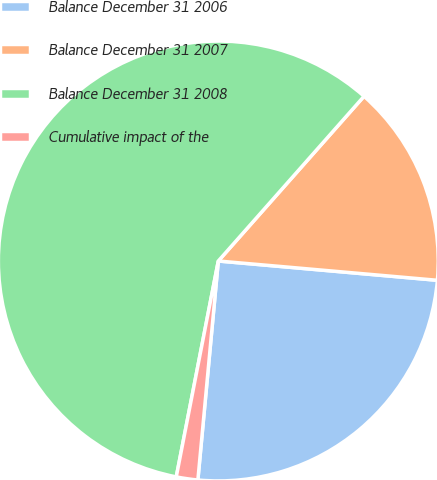<chart> <loc_0><loc_0><loc_500><loc_500><pie_chart><fcel>Balance December 31 2006<fcel>Balance December 31 2007<fcel>Balance December 31 2008<fcel>Cumulative impact of the<nl><fcel>25.08%<fcel>14.87%<fcel>58.46%<fcel>1.58%<nl></chart> 